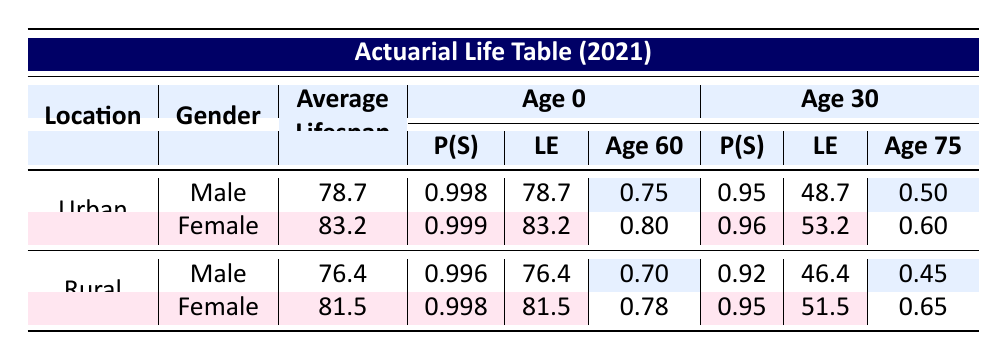What is the average lifespan for urban females? In the table, under the "Urban" location type and "Female" gender, the average lifespan is clearly stated as 83.2.
Answer: 83.2 What is the probability of survival for rural males at the age of 30? The table shows that for "Rural" males at "Age 30," the probability of survival (P(S)) is noted as 0.92.
Answer: 0.92 Is the average lifespan for urban males greater than that for rural males? The average lifespan for urban males is 78.7 while for rural males it is 76.4. Since 78.7 is greater than 76.4, the statement is true.
Answer: Yes What is the difference in average lifespan between urban females and rural females? The average lifespan for urban females is 83.2, while for rural females it is 81.5. The difference is calculated as 83.2 - 81.5 = 1.7.
Answer: 1.7 What is the life expectancy for a rural male at age 75? From the table, the life expectancy for "Rural" males at "Age 75" is indicated as 1.4.
Answer: 1.4 What is the average probability of survival for urban females at age 60 and 75? The probabilities of survival for urban females at age 60 and 75 are 0.80 and 0.60, respectively. To find the average, we calculate (0.80 + 0.60) / 2 = 0.70.
Answer: 0.70 How does the average lifespan of rural males compare to that of urban males? The average lifespan for rural males is 76.4 and for urban males it is 78.7. Since 76.4 is less than 78.7, rural males have a shorter average lifespan than urban males.
Answer: Rural males have a shorter lifespan What is the life expectancy for a female at age 60 in urban areas? Looking at the table for "Urban" females at "Age 60," the life expectancy (LE) is 23.2.
Answer: 23.2 